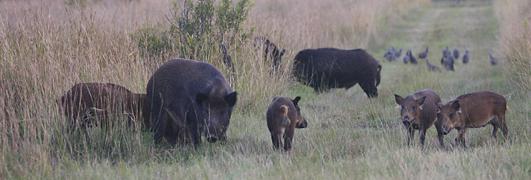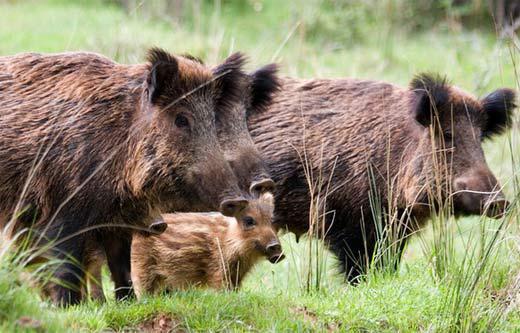The first image is the image on the left, the second image is the image on the right. Considering the images on both sides, is "An image contains multiple dark adult boars, and at least seven striped juvenile pigs." valid? Answer yes or no. No. The first image is the image on the left, the second image is the image on the right. Examine the images to the left and right. Is the description "All boars in the right image are facing right." accurate? Answer yes or no. Yes. 